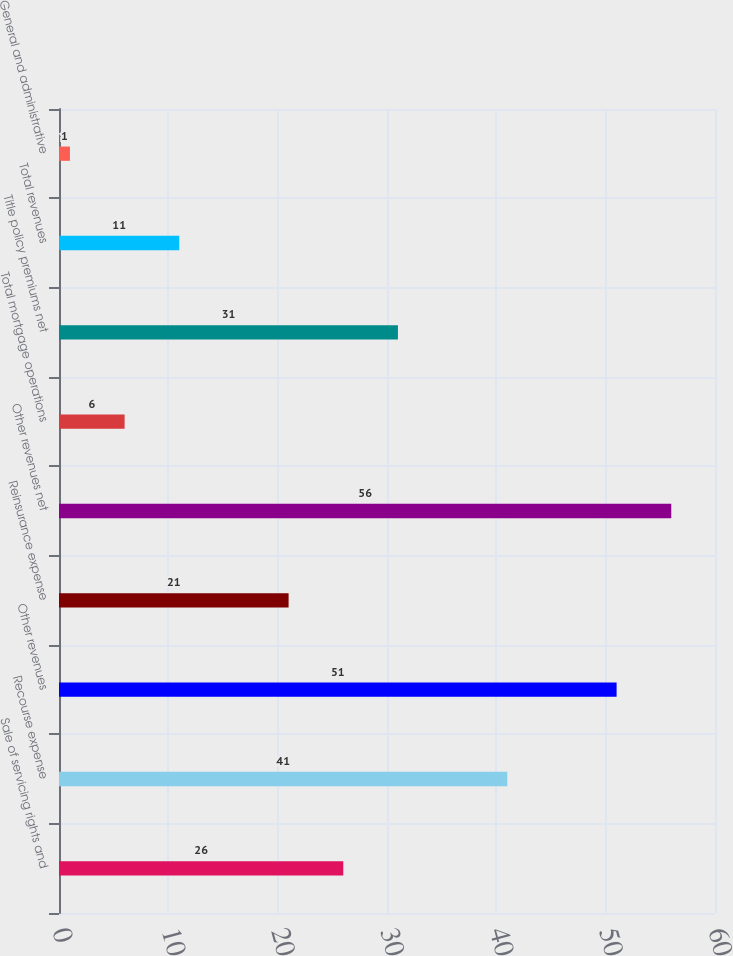Convert chart to OTSL. <chart><loc_0><loc_0><loc_500><loc_500><bar_chart><fcel>Sale of servicing rights and<fcel>Recourse expense<fcel>Other revenues<fcel>Reinsurance expense<fcel>Other revenues net<fcel>Total mortgage operations<fcel>Title policy premiums net<fcel>Total revenues<fcel>General and administrative<nl><fcel>26<fcel>41<fcel>51<fcel>21<fcel>56<fcel>6<fcel>31<fcel>11<fcel>1<nl></chart> 